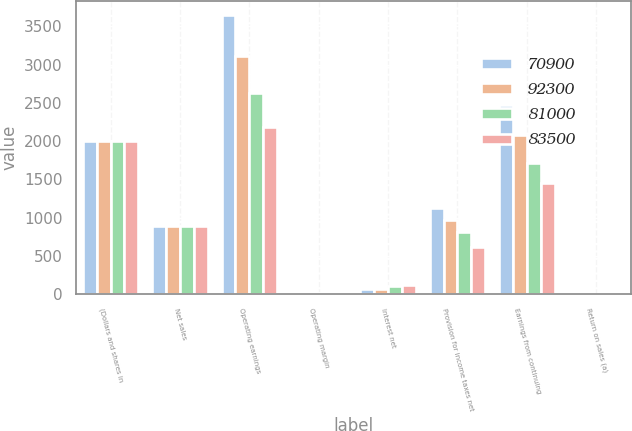Convert chart to OTSL. <chart><loc_0><loc_0><loc_500><loc_500><stacked_bar_chart><ecel><fcel>(Dollars and shares in<fcel>Net sales<fcel>Operating earnings<fcel>Operating margin<fcel>Interest net<fcel>Provision for income taxes net<fcel>Earnings from continuing<fcel>Return on sales (a)<nl><fcel>70900<fcel>2008<fcel>892<fcel>3653<fcel>12.5<fcel>66<fcel>1126<fcel>2478<fcel>8.5<nl><fcel>92300<fcel>2007<fcel>892<fcel>3113<fcel>11.4<fcel>70<fcel>967<fcel>2080<fcel>7.6<nl><fcel>81000<fcel>2006<fcel>892<fcel>2625<fcel>10.9<fcel>101<fcel>817<fcel>1710<fcel>7.1<nl><fcel>83500<fcel>2005<fcel>892<fcel>2179<fcel>10.4<fcel>118<fcel>621<fcel>1448<fcel>6.9<nl></chart> 